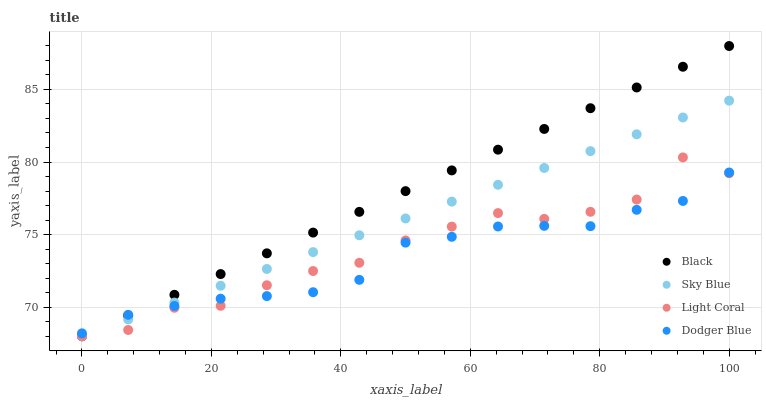Does Dodger Blue have the minimum area under the curve?
Answer yes or no. Yes. Does Black have the maximum area under the curve?
Answer yes or no. Yes. Does Sky Blue have the minimum area under the curve?
Answer yes or no. No. Does Sky Blue have the maximum area under the curve?
Answer yes or no. No. Is Black the smoothest?
Answer yes or no. Yes. Is Light Coral the roughest?
Answer yes or no. Yes. Is Sky Blue the smoothest?
Answer yes or no. No. Is Sky Blue the roughest?
Answer yes or no. No. Does Light Coral have the lowest value?
Answer yes or no. Yes. Does Dodger Blue have the lowest value?
Answer yes or no. No. Does Black have the highest value?
Answer yes or no. Yes. Does Sky Blue have the highest value?
Answer yes or no. No. Does Black intersect Dodger Blue?
Answer yes or no. Yes. Is Black less than Dodger Blue?
Answer yes or no. No. Is Black greater than Dodger Blue?
Answer yes or no. No. 